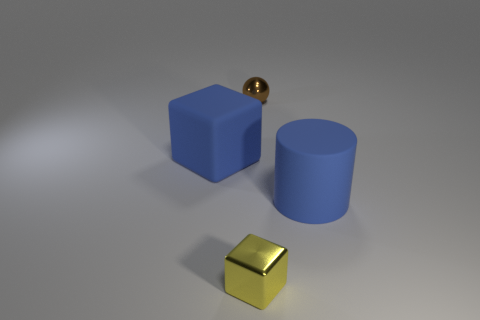Is there any other thing that is the same shape as the tiny brown thing?
Offer a very short reply. No. Is there a brown sphere that has the same material as the cylinder?
Provide a succinct answer. No. Do the tiny yellow object and the small ball have the same material?
Your response must be concise. Yes. There is a metallic object that is the same size as the sphere; what is its color?
Provide a short and direct response. Yellow. What number of other things are the same shape as the brown object?
Offer a very short reply. 0. There is a brown sphere; is it the same size as the rubber thing that is right of the small block?
Your answer should be very brief. No. How many things are small blue matte cylinders or rubber cubes?
Your answer should be compact. 1. How many other objects are there of the same size as the blue cube?
Your answer should be compact. 1. Is the color of the cylinder the same as the thing on the left side of the yellow metal cube?
Give a very brief answer. Yes. What number of blocks are tiny purple rubber objects or small brown things?
Give a very brief answer. 0. 